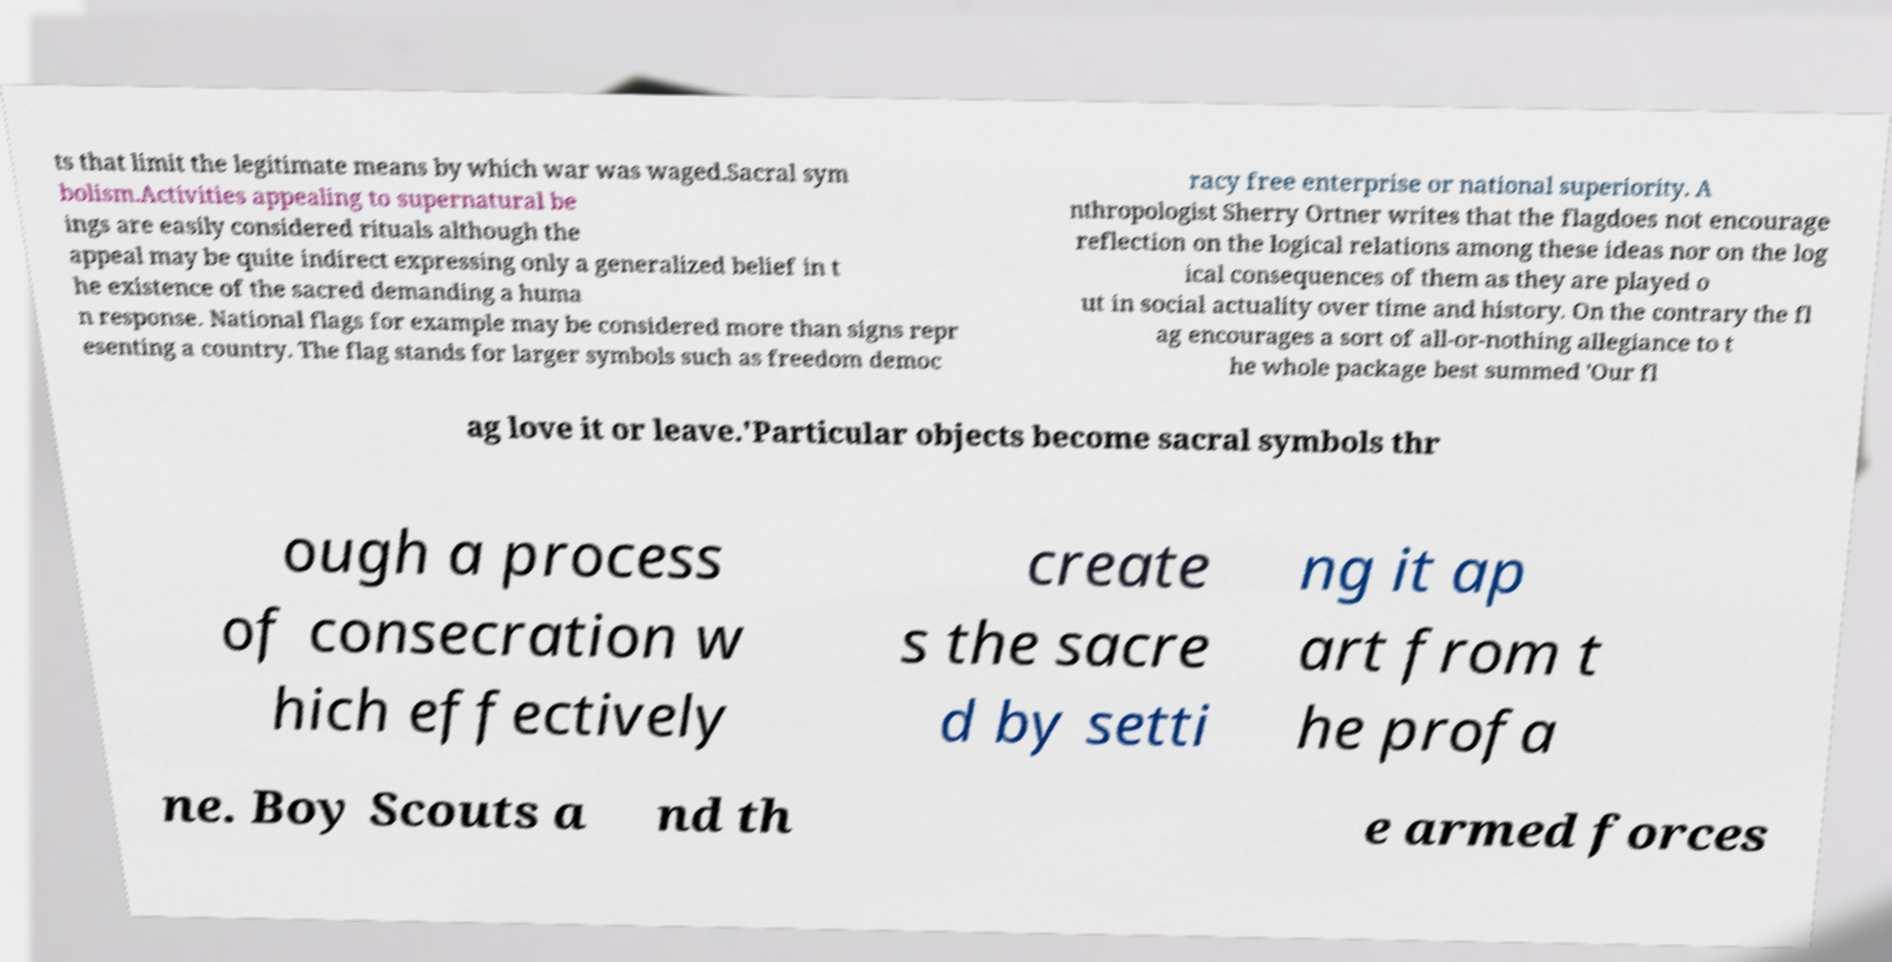Could you extract and type out the text from this image? ts that limit the legitimate means by which war was waged.Sacral sym bolism.Activities appealing to supernatural be ings are easily considered rituals although the appeal may be quite indirect expressing only a generalized belief in t he existence of the sacred demanding a huma n response. National flags for example may be considered more than signs repr esenting a country. The flag stands for larger symbols such as freedom democ racy free enterprise or national superiority. A nthropologist Sherry Ortner writes that the flagdoes not encourage reflection on the logical relations among these ideas nor on the log ical consequences of them as they are played o ut in social actuality over time and history. On the contrary the fl ag encourages a sort of all-or-nothing allegiance to t he whole package best summed 'Our fl ag love it or leave.'Particular objects become sacral symbols thr ough a process of consecration w hich effectively create s the sacre d by setti ng it ap art from t he profa ne. Boy Scouts a nd th e armed forces 